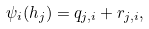Convert formula to latex. <formula><loc_0><loc_0><loc_500><loc_500>\psi _ { i } ( h _ { j } ) = q _ { j , i } + r _ { j , i } ,</formula> 